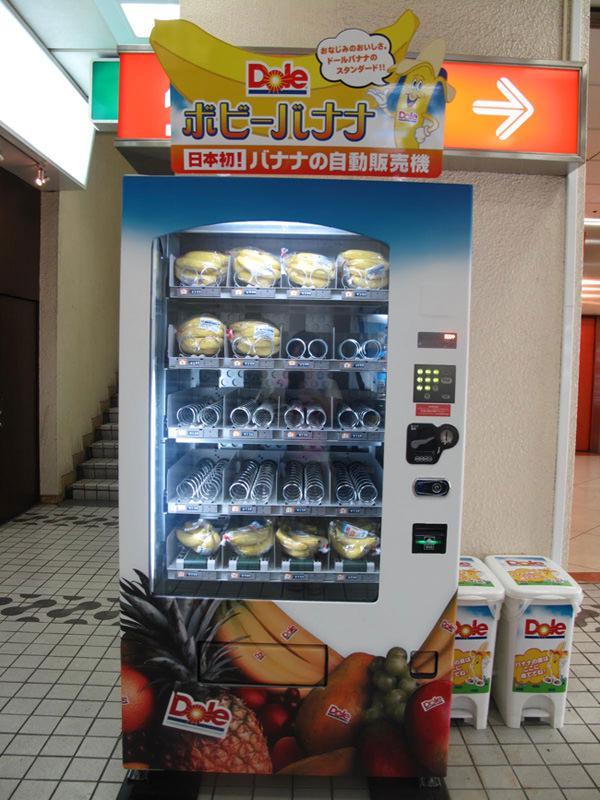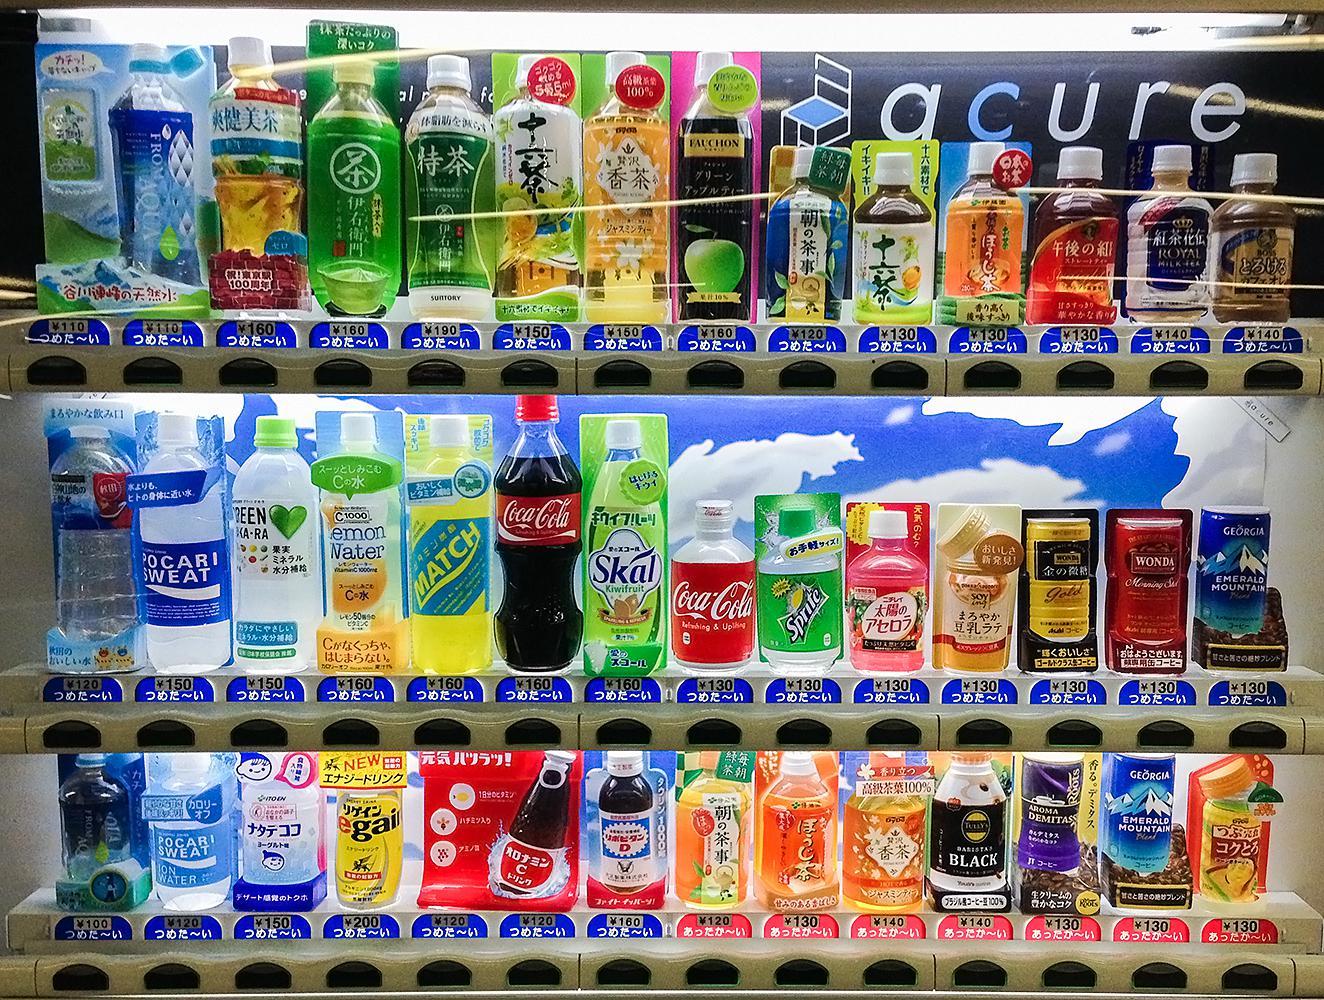The first image is the image on the left, the second image is the image on the right. For the images displayed, is the sentence "A dark-haired young man in a suit jacket is in the right of one image." factually correct? Answer yes or no. No. The first image is the image on the left, the second image is the image on the right. Considering the images on both sides, is "there is a person in one of the iamges." valid? Answer yes or no. No. 